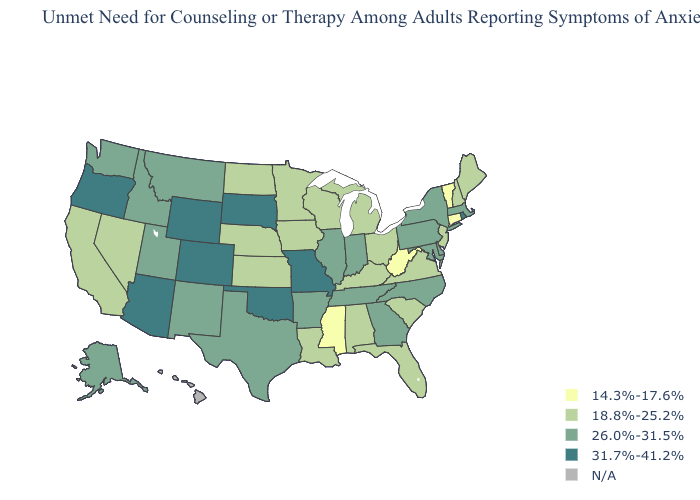What is the value of Nevada?
Write a very short answer. 18.8%-25.2%. Which states hav the highest value in the Northeast?
Answer briefly. Rhode Island. Which states have the lowest value in the South?
Quick response, please. Mississippi, West Virginia. What is the highest value in the MidWest ?
Concise answer only. 31.7%-41.2%. What is the value of Vermont?
Write a very short answer. 14.3%-17.6%. Is the legend a continuous bar?
Answer briefly. No. What is the lowest value in states that border South Carolina?
Keep it brief. 26.0%-31.5%. What is the highest value in states that border Arkansas?
Quick response, please. 31.7%-41.2%. What is the lowest value in the West?
Short answer required. 18.8%-25.2%. What is the value of Vermont?
Short answer required. 14.3%-17.6%. What is the value of New Mexico?
Write a very short answer. 26.0%-31.5%. What is the value of Illinois?
Concise answer only. 26.0%-31.5%. 